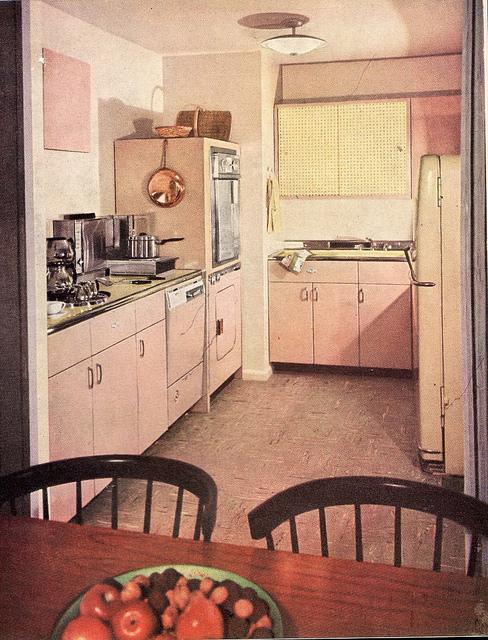What is this room called?
Write a very short answer. Kitchen. Are the fruits real?
Write a very short answer. Yes. Is there fruit on the table?
Short answer required. Yes. What room of a house is this?
Concise answer only. Kitchen. How many chairs can be seen?
Keep it brief. 2. 